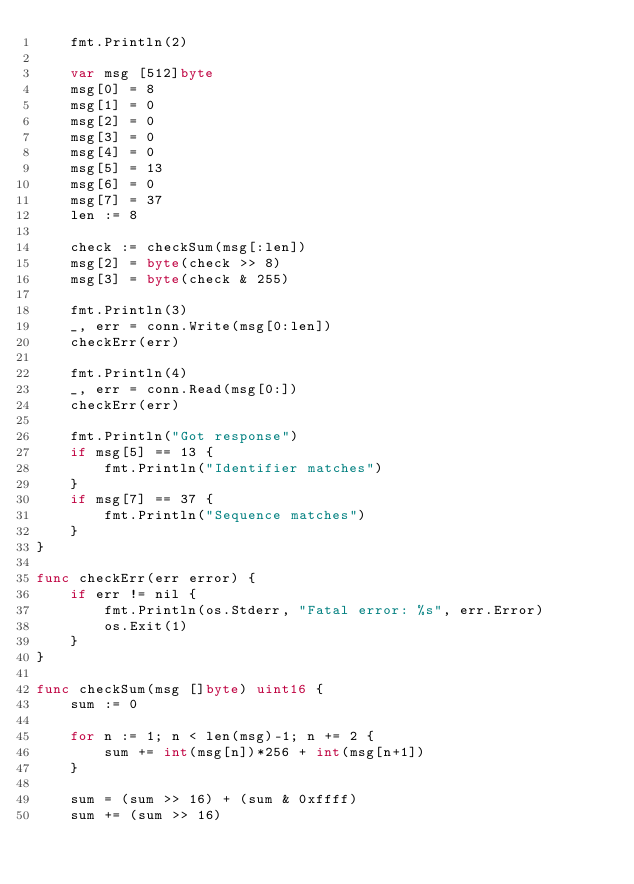<code> <loc_0><loc_0><loc_500><loc_500><_Go_>	fmt.Println(2)

	var msg [512]byte
	msg[0] = 8
	msg[1] = 0
	msg[2] = 0
	msg[3] = 0
	msg[4] = 0
	msg[5] = 13
	msg[6] = 0
	msg[7] = 37
	len := 8

	check := checkSum(msg[:len])
	msg[2] = byte(check >> 8)
	msg[3] = byte(check & 255)

	fmt.Println(3)
	_, err = conn.Write(msg[0:len])
	checkErr(err)

	fmt.Println(4)
	_, err = conn.Read(msg[0:])
	checkErr(err)

	fmt.Println("Got response")
	if msg[5] == 13 {
		fmt.Println("Identifier matches")
	}
	if msg[7] == 37 {
		fmt.Println("Sequence matches")
	}
}

func checkErr(err error) {
	if err != nil {
		fmt.Println(os.Stderr, "Fatal error: %s", err.Error)
		os.Exit(1)
	}
}

func checkSum(msg []byte) uint16 {
	sum := 0

	for n := 1; n < len(msg)-1; n += 2 {
		sum += int(msg[n])*256 + int(msg[n+1])
	}

	sum = (sum >> 16) + (sum & 0xffff)
	sum += (sum >> 16)</code> 